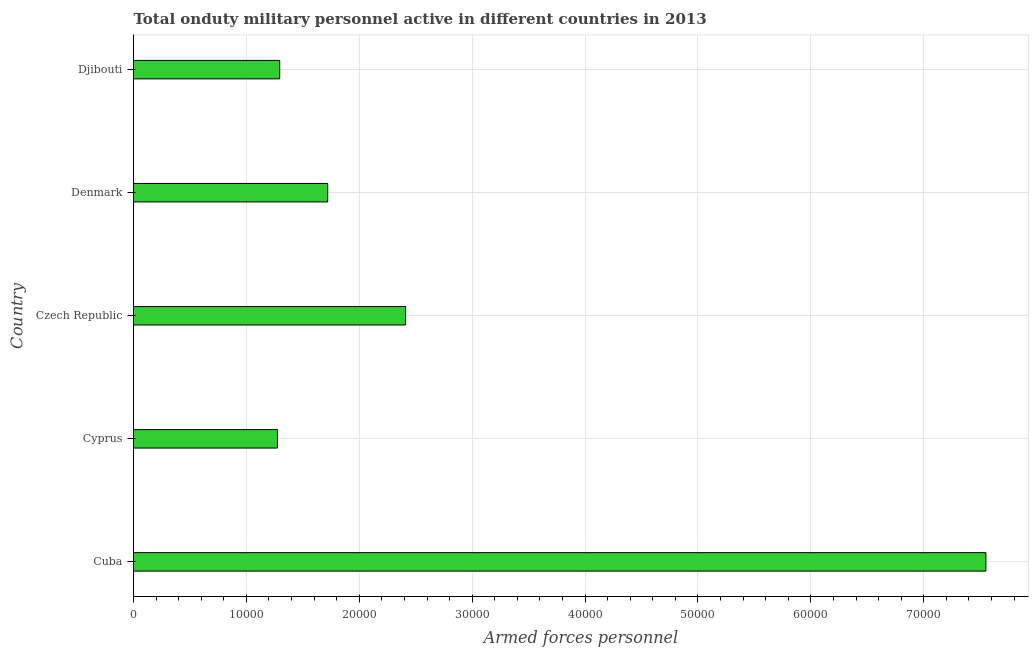Does the graph contain grids?
Ensure brevity in your answer.  Yes. What is the title of the graph?
Your response must be concise. Total onduty military personnel active in different countries in 2013. What is the label or title of the X-axis?
Provide a succinct answer. Armed forces personnel. What is the label or title of the Y-axis?
Give a very brief answer. Country. What is the number of armed forces personnel in Czech Republic?
Your answer should be compact. 2.41e+04. Across all countries, what is the maximum number of armed forces personnel?
Your response must be concise. 7.55e+04. Across all countries, what is the minimum number of armed forces personnel?
Offer a terse response. 1.28e+04. In which country was the number of armed forces personnel maximum?
Your answer should be very brief. Cuba. In which country was the number of armed forces personnel minimum?
Your answer should be compact. Cyprus. What is the sum of the number of armed forces personnel?
Provide a succinct answer. 1.42e+05. What is the difference between the number of armed forces personnel in Czech Republic and Denmark?
Offer a terse response. 6900. What is the average number of armed forces personnel per country?
Keep it short and to the point. 2.85e+04. What is the median number of armed forces personnel?
Your answer should be compact. 1.72e+04. What is the ratio of the number of armed forces personnel in Cyprus to that in Denmark?
Give a very brief answer. 0.74. Is the difference between the number of armed forces personnel in Denmark and Djibouti greater than the difference between any two countries?
Provide a succinct answer. No. What is the difference between the highest and the second highest number of armed forces personnel?
Offer a terse response. 5.14e+04. Is the sum of the number of armed forces personnel in Denmark and Djibouti greater than the maximum number of armed forces personnel across all countries?
Your answer should be compact. No. What is the difference between the highest and the lowest number of armed forces personnel?
Offer a terse response. 6.28e+04. In how many countries, is the number of armed forces personnel greater than the average number of armed forces personnel taken over all countries?
Offer a terse response. 1. How many bars are there?
Offer a terse response. 5. How many countries are there in the graph?
Ensure brevity in your answer.  5. What is the Armed forces personnel of Cuba?
Your answer should be compact. 7.55e+04. What is the Armed forces personnel of Cyprus?
Your answer should be compact. 1.28e+04. What is the Armed forces personnel of Czech Republic?
Make the answer very short. 2.41e+04. What is the Armed forces personnel of Denmark?
Ensure brevity in your answer.  1.72e+04. What is the Armed forces personnel of Djibouti?
Provide a succinct answer. 1.30e+04. What is the difference between the Armed forces personnel in Cuba and Cyprus?
Offer a terse response. 6.28e+04. What is the difference between the Armed forces personnel in Cuba and Czech Republic?
Your answer should be very brief. 5.14e+04. What is the difference between the Armed forces personnel in Cuba and Denmark?
Your response must be concise. 5.83e+04. What is the difference between the Armed forces personnel in Cuba and Djibouti?
Your answer should be very brief. 6.26e+04. What is the difference between the Armed forces personnel in Cyprus and Czech Republic?
Ensure brevity in your answer.  -1.14e+04. What is the difference between the Armed forces personnel in Cyprus and Denmark?
Keep it short and to the point. -4450. What is the difference between the Armed forces personnel in Cyprus and Djibouti?
Your response must be concise. -200. What is the difference between the Armed forces personnel in Czech Republic and Denmark?
Your response must be concise. 6900. What is the difference between the Armed forces personnel in Czech Republic and Djibouti?
Your answer should be compact. 1.12e+04. What is the difference between the Armed forces personnel in Denmark and Djibouti?
Your response must be concise. 4250. What is the ratio of the Armed forces personnel in Cuba to that in Cyprus?
Provide a succinct answer. 5.92. What is the ratio of the Armed forces personnel in Cuba to that in Czech Republic?
Your response must be concise. 3.13. What is the ratio of the Armed forces personnel in Cuba to that in Denmark?
Your answer should be very brief. 4.39. What is the ratio of the Armed forces personnel in Cuba to that in Djibouti?
Provide a short and direct response. 5.83. What is the ratio of the Armed forces personnel in Cyprus to that in Czech Republic?
Give a very brief answer. 0.53. What is the ratio of the Armed forces personnel in Cyprus to that in Denmark?
Offer a terse response. 0.74. What is the ratio of the Armed forces personnel in Cyprus to that in Djibouti?
Keep it short and to the point. 0.98. What is the ratio of the Armed forces personnel in Czech Republic to that in Denmark?
Give a very brief answer. 1.4. What is the ratio of the Armed forces personnel in Czech Republic to that in Djibouti?
Provide a short and direct response. 1.86. What is the ratio of the Armed forces personnel in Denmark to that in Djibouti?
Keep it short and to the point. 1.33. 